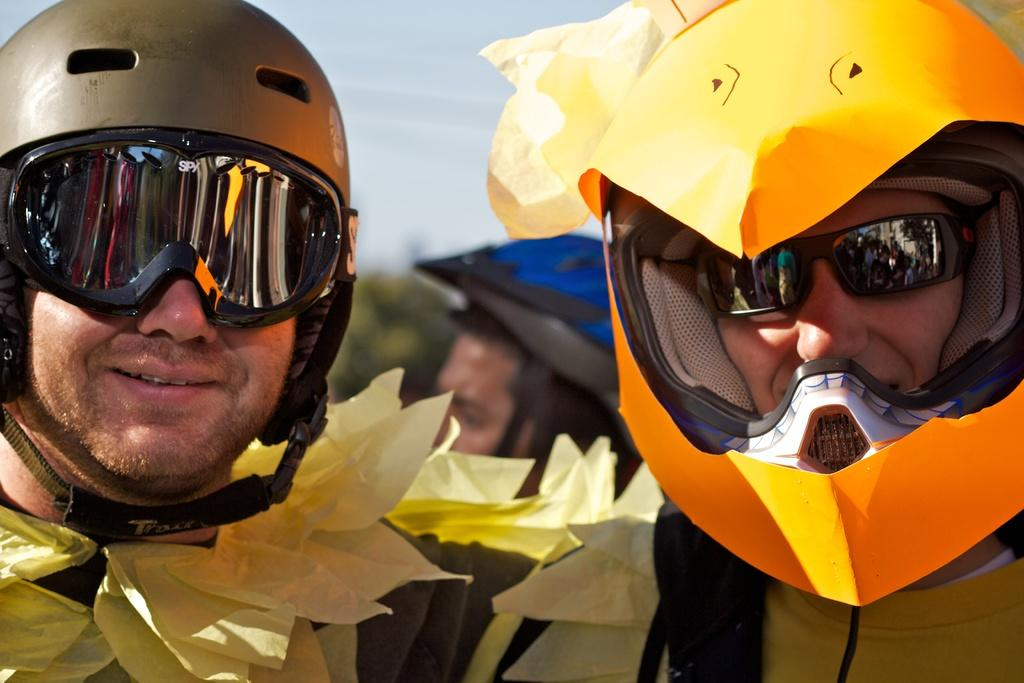How many people are in the image? There are three persons in the image. What are the persons wearing on their heads? The persons are wearing helmets. What can be seen at the top of the image? The sky is visible at the top of the image. How would you describe the background of the image? The background of the image is blurry. Can you see any beads on the persons' lips in the image? There are no beads or lips visible on the persons in the image, as they are wearing helmets that cover their heads. 